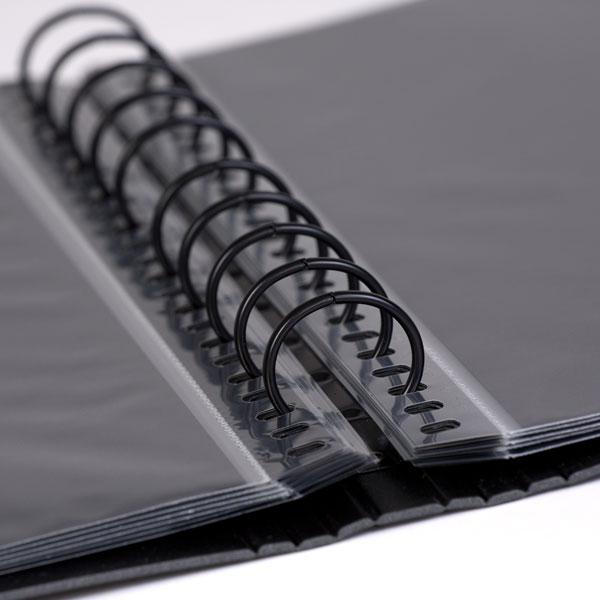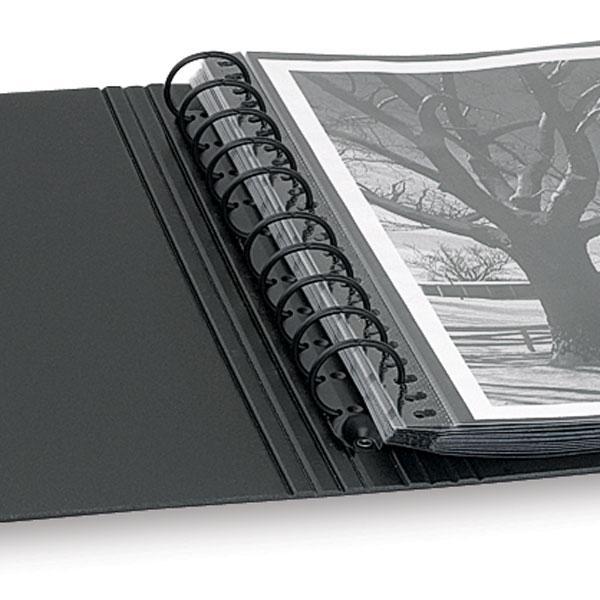The first image is the image on the left, the second image is the image on the right. Considering the images on both sides, is "Two solid black notebook binders with center rings are in the open position." valid? Answer yes or no. Yes. The first image is the image on the left, the second image is the image on the right. For the images displayed, is the sentence "At least one image shows one closed black binder with a colored label on the front." factually correct? Answer yes or no. No. 